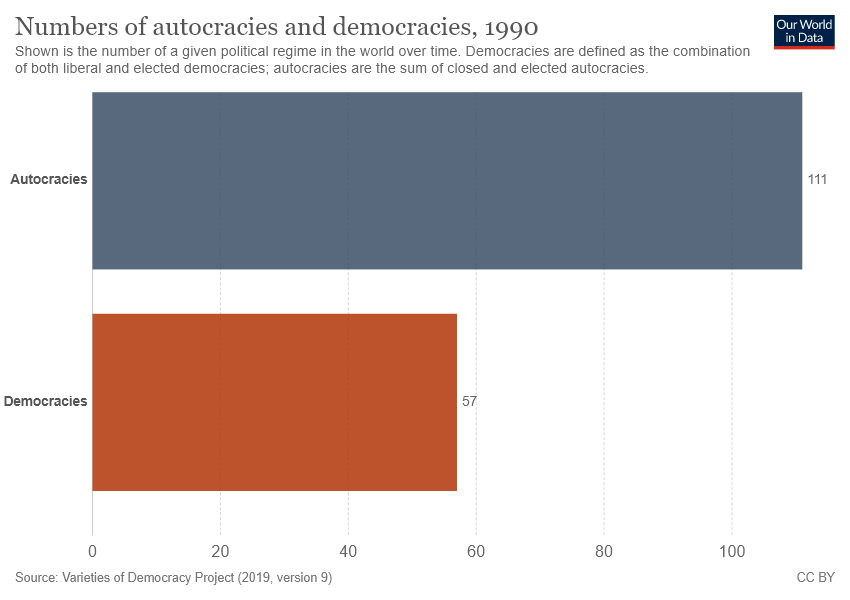Give some essential details in this illustration. The color of the smallest bar is brown. The average of two bars is 84. 